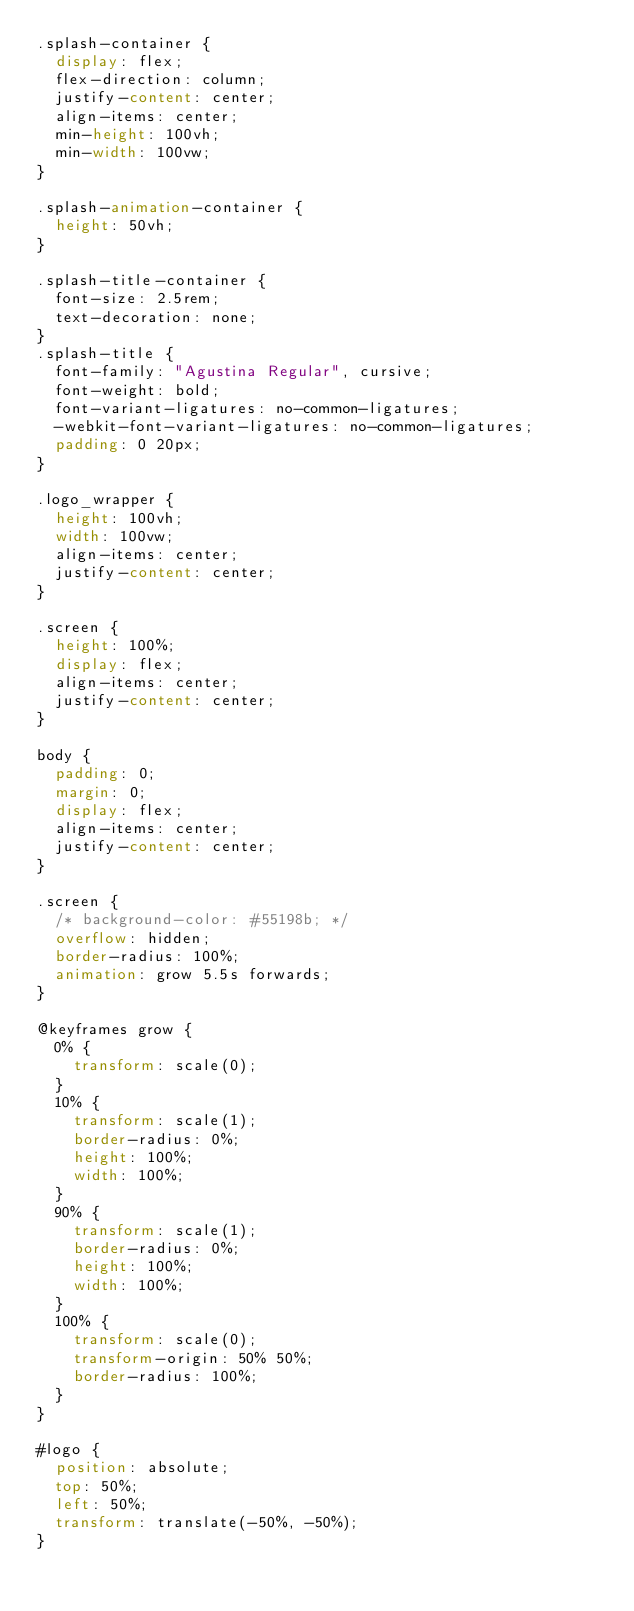<code> <loc_0><loc_0><loc_500><loc_500><_CSS_>.splash-container {
  display: flex;
  flex-direction: column;
  justify-content: center;
  align-items: center;
  min-height: 100vh;
  min-width: 100vw;
}

.splash-animation-container {
  height: 50vh;
}

.splash-title-container {
  font-size: 2.5rem;
  text-decoration: none;
}
.splash-title {
  font-family: "Agustina Regular", cursive;
  font-weight: bold;
  font-variant-ligatures: no-common-ligatures;
  -webkit-font-variant-ligatures: no-common-ligatures;
  padding: 0 20px;
}

.logo_wrapper {
  height: 100vh;
  width: 100vw;
  align-items: center;
  justify-content: center;
}

.screen {
  height: 100%;
  display: flex;
  align-items: center;
  justify-content: center;
}

body {
  padding: 0;
  margin: 0;
  display: flex;
  align-items: center;
  justify-content: center;
}

.screen {
  /* background-color: #55198b; */
  overflow: hidden;
  border-radius: 100%;
  animation: grow 5.5s forwards;
}

@keyframes grow {
  0% {
    transform: scale(0);
  }
  10% {
    transform: scale(1);
    border-radius: 0%;
    height: 100%;
    width: 100%;
  }
  90% {
    transform: scale(1);
    border-radius: 0%;
    height: 100%;
    width: 100%;
  }
  100% {
    transform: scale(0);
    transform-origin: 50% 50%;
    border-radius: 100%;
  }
}

#logo {
  position: absolute;
  top: 50%;
  left: 50%;
  transform: translate(-50%, -50%);
}
</code> 